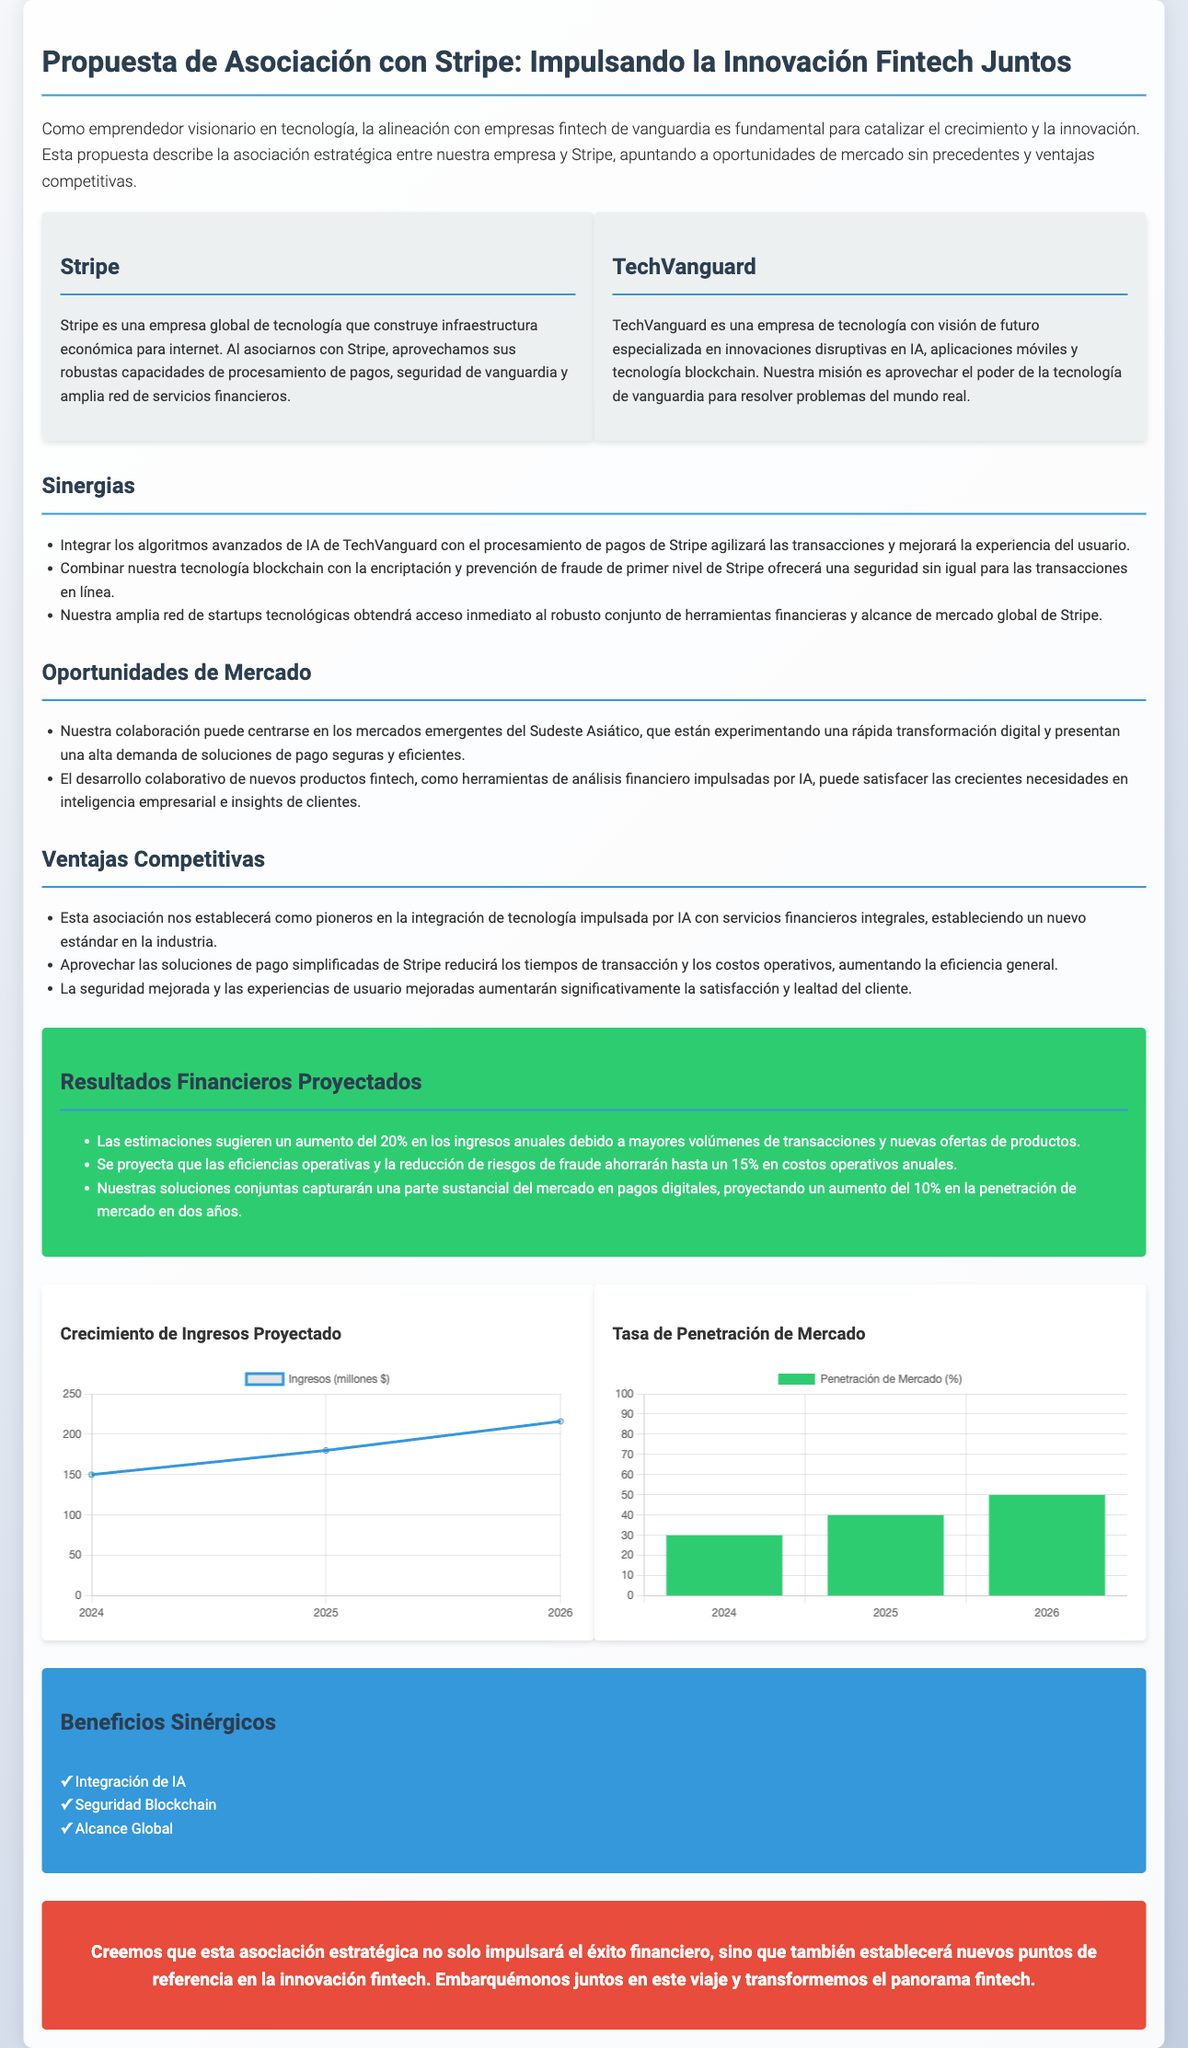¿Qué empresa se menciona en la propuesta? La empresa mencionada en la propuesta es Stripe, la cual es una empresa de tecnología que construye infraestructura económica para internet.
Answer: Stripe ¿Cuáles son las sinergias propuestas? Las sinergias incluyen la integración de IA, la combinación de tecnología blockchain y la amplia red de startups tecnológicas.
Answer: Integrar los algoritmos avanzados de IA de TechVanguard con el procesamiento de pagos de Stripe agilizará las transacciones y mejorará la experiencia del usuario ¿Cuáles son las oportunidades de mercado destacadas? Se centra en los mercados emergentes del Sudeste Asiático y en el desarrollo de nuevos productos fintech.
Answer: Los mercados emergentes del Sudeste Asiático ¿Qué porcentaje se proyecta para el aumento de ingresos anuales? Se estima que habrá un aumento del 20% en los ingresos anuales debido a mayores volúmenes de transacciones.
Answer: 20% ¿Cuál es el incremento proyectado en la penetración de mercado en dos años? La propuesta menciona un aumento del 10% en la penetración de mercado en dos años.
Answer: 10% ¿Cuáles son las ventajas competitivas de la asociación? Las ventajas competitivas incluyen la integración de tecnología impulsada por IA y mejoras en seguridad y experiencia del usuario.
Answer: Ser pioneros en la integración de tecnología impulsada por IA con servicios financieros ¿Qué representa la gráfica "Crecimiento de Ingresos Proyectado"? La gráfica muestra el aumento estimado de ingresos en millones de dólares para los años 2024, 2025 y 2026.
Answer: Ingresos (millones $) ¿Cuáles son los beneficios sinérgicos mencionados en la infografía? Los beneficios sinérgicos incluyen la integración de IA, seguridad blockchain, y alcance global.
Answer: Integración de IA ¿Qué año se menciona como el inicio del crecimiento en la proyección de ingresos? El comienzo del crecimiento se establece a partir del año 2024.
Answer: 2024 